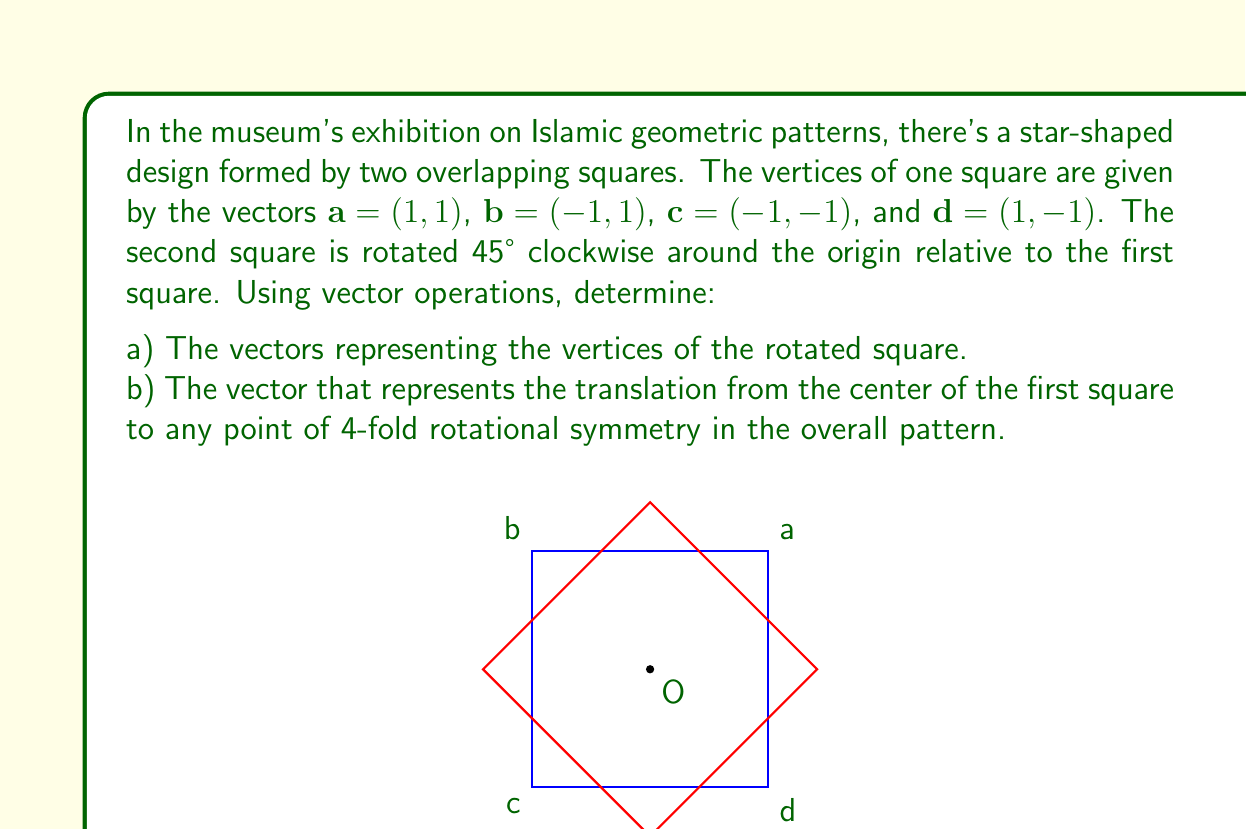Can you answer this question? Let's approach this problem step by step:

a) To find the vertices of the rotated square:

1) The rotation matrix for a 45° clockwise rotation is:
   $$R = \begin{pmatrix} \cos(-45°) & -\sin(-45°) \\ \sin(-45°) & \cos(-45°) \end{pmatrix} = \begin{pmatrix} \frac{\sqrt{2}}{2} & \frac{\sqrt{2}}{2} \\ -\frac{\sqrt{2}}{2} & \frac{\sqrt{2}}{2} \end{pmatrix}$$

2) We need to multiply each vertex vector by this rotation matrix:

   For $\mathbf{a'} = R\mathbf{a}$:
   $$\begin{pmatrix} \frac{\sqrt{2}}{2} & \frac{\sqrt{2}}{2} \\ -\frac{\sqrt{2}}{2} & \frac{\sqrt{2}}{2} \end{pmatrix} \begin{pmatrix} 1 \\ 1 \end{pmatrix} = \begin{pmatrix} \sqrt{2} \\ 0 \end{pmatrix}$$

   Similarly, we can calculate:
   $\mathbf{b'} = (0, \sqrt{2})$
   $\mathbf{c'} = (-\sqrt{2}, 0)$
   $\mathbf{d'} = (0, -\sqrt{2})$

b) To find the translation vector to a point of 4-fold rotational symmetry:

1) The center of the first square is at $(0, 0)$, as it's centered on the origin.

2) The points of 4-fold rotational symmetry are where the diagonals of both squares intersect. These are at $(\frac{1}{2}, \frac{1}{2})$, $(-\frac{1}{2}, \frac{1}{2})$, $(-\frac{1}{2}, -\frac{1}{2})$, and $(\frac{1}{2}, -\frac{1}{2})$.

3) The translation vector from the center to any of these points is the vector representation of that point. We can choose any of them, let's pick $(\frac{1}{2}, \frac{1}{2})$.

Therefore, the translation vector is $\mathbf{t} = (\frac{1}{2}, \frac{1}{2})$.
Answer: a) The vectors representing the vertices of the rotated square are:
   $\mathbf{a'} = (\sqrt{2}, 0)$
   $\mathbf{b'} = (0, \sqrt{2})$
   $\mathbf{c'} = (-\sqrt{2}, 0)$
   $\mathbf{d'} = (0, -\sqrt{2})$

b) The translation vector from the center of the first square to a point of 4-fold rotational symmetry is $\mathbf{t} = (\frac{1}{2}, \frac{1}{2})$. 